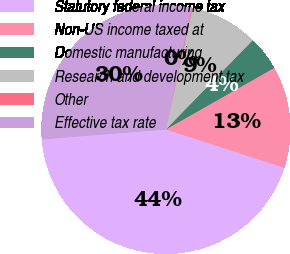Convert chart. <chart><loc_0><loc_0><loc_500><loc_500><pie_chart><fcel>Statutory federal income tax<fcel>Non-US income taxed at<fcel>Domestic manufacturing<fcel>Research and development tax<fcel>Other<fcel>Effective tax rate<nl><fcel>43.73%<fcel>13.21%<fcel>4.49%<fcel>8.85%<fcel>0.12%<fcel>29.61%<nl></chart> 